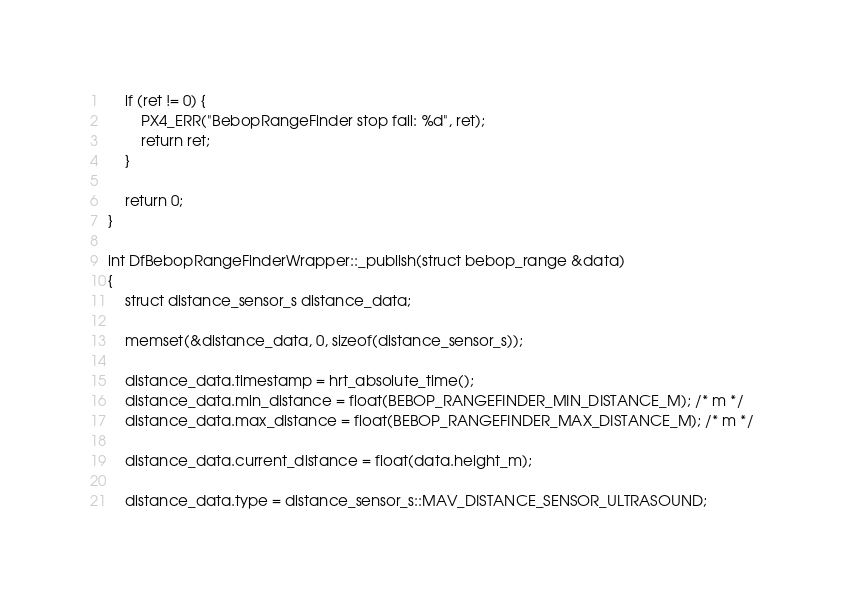<code> <loc_0><loc_0><loc_500><loc_500><_C++_>	if (ret != 0) {
		PX4_ERR("BebopRangeFinder stop fail: %d", ret);
		return ret;
	}

	return 0;
}

int DfBebopRangeFinderWrapper::_publish(struct bebop_range &data)
{
	struct distance_sensor_s distance_data;

	memset(&distance_data, 0, sizeof(distance_sensor_s));

	distance_data.timestamp = hrt_absolute_time();
	distance_data.min_distance = float(BEBOP_RANGEFINDER_MIN_DISTANCE_M); /* m */
	distance_data.max_distance = float(BEBOP_RANGEFINDER_MAX_DISTANCE_M); /* m */

	distance_data.current_distance = float(data.height_m);

	distance_data.type = distance_sensor_s::MAV_DISTANCE_SENSOR_ULTRASOUND;
</code> 